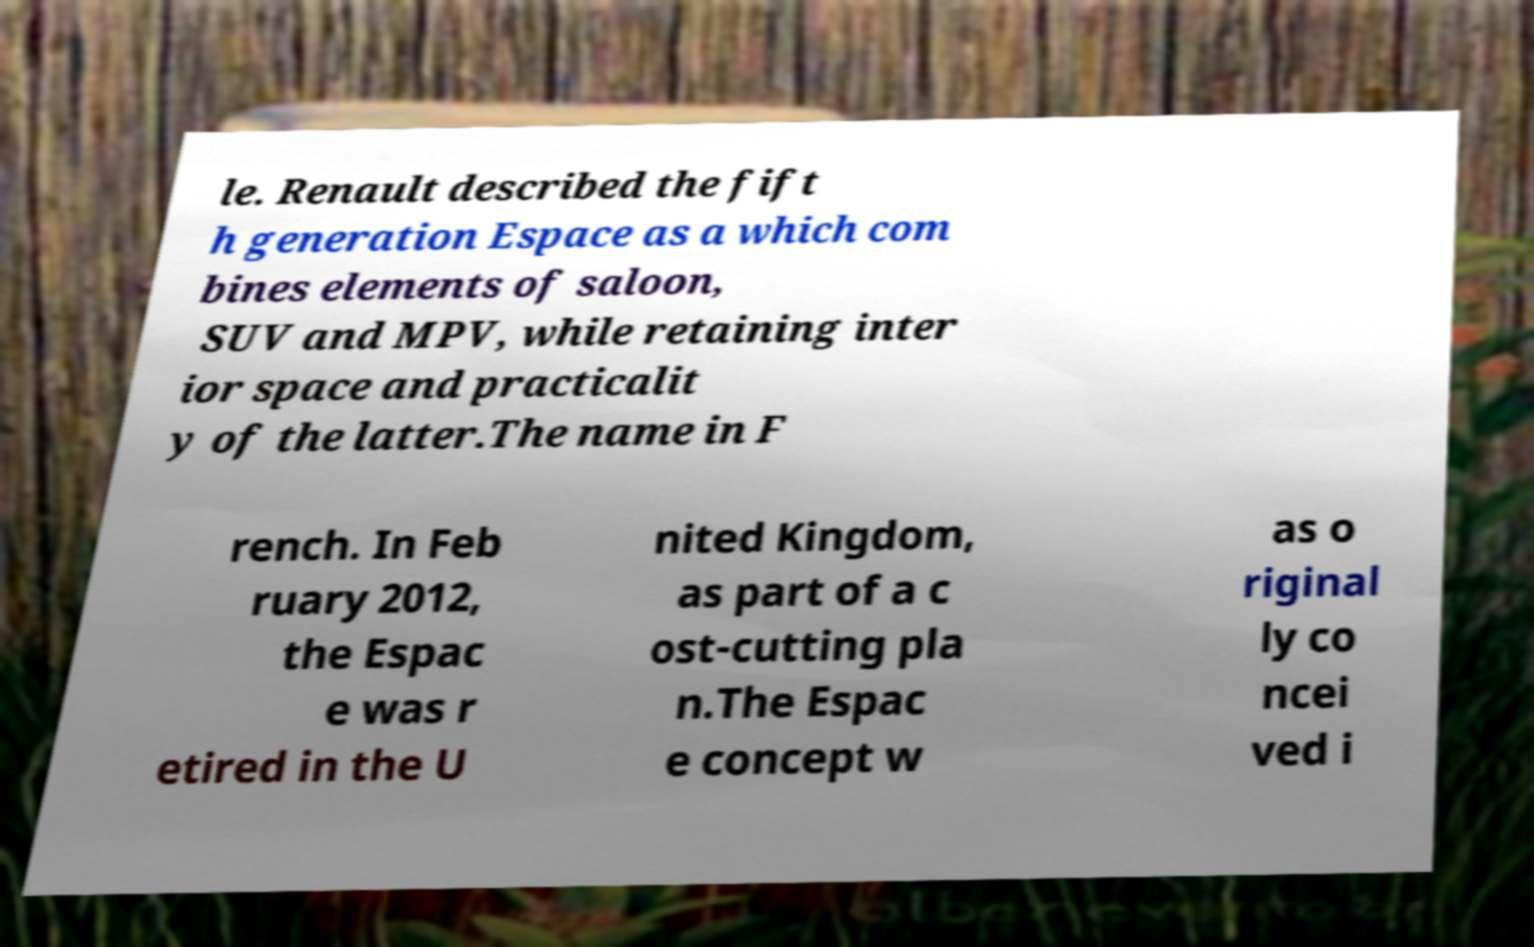What messages or text are displayed in this image? I need them in a readable, typed format. le. Renault described the fift h generation Espace as a which com bines elements of saloon, SUV and MPV, while retaining inter ior space and practicalit y of the latter.The name in F rench. In Feb ruary 2012, the Espac e was r etired in the U nited Kingdom, as part of a c ost-cutting pla n.The Espac e concept w as o riginal ly co ncei ved i 